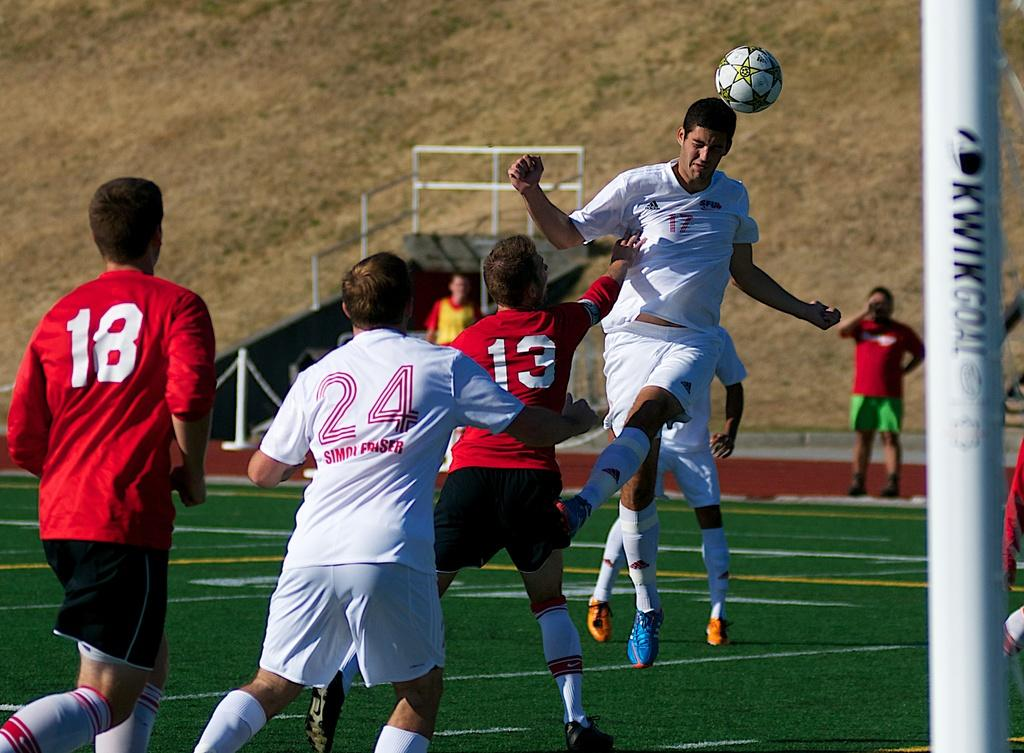Where is the image taken? The image is taken on the ground. What activity are the people engaged in? The people are playing football. What color is the grass in the background? The grass in the background is brown-colored. What brand of toothpaste is being advertised in the image? There is no toothpaste or advertisement present in the image. What rule is being enforced by the referee in the image? There is no referee or rule enforcement present in the image. 